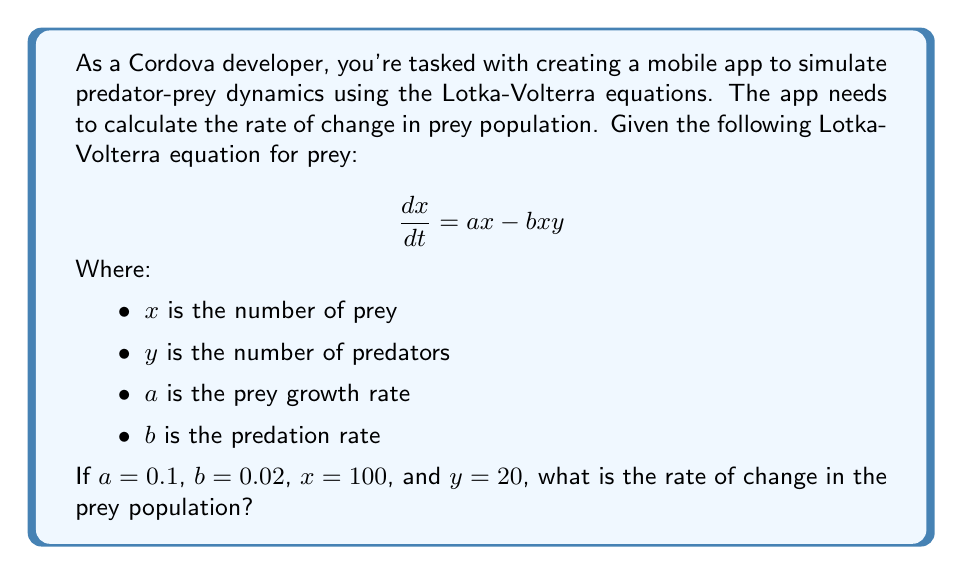Give your solution to this math problem. To solve this problem, we'll follow these steps:

1. Identify the given values:
   $a = 0.1$ (prey growth rate)
   $b = 0.02$ (predation rate)
   $x = 100$ (number of prey)
   $y = 20$ (number of predators)

2. Substitute these values into the Lotka-Volterra equation for prey:
   $$\frac{dx}{dt} = ax - bxy$$

3. Calculate the first term ($ax$):
   $ax = 0.1 \times 100 = 10$

4. Calculate the second term ($bxy$):
   $bxy = 0.02 \times 100 \times 20 = 40$

5. Subtract the second term from the first term:
   $$\frac{dx}{dt} = 10 - 40 = -30$$

The negative value indicates that the prey population is decreasing.
Answer: $-30$ prey per unit time 